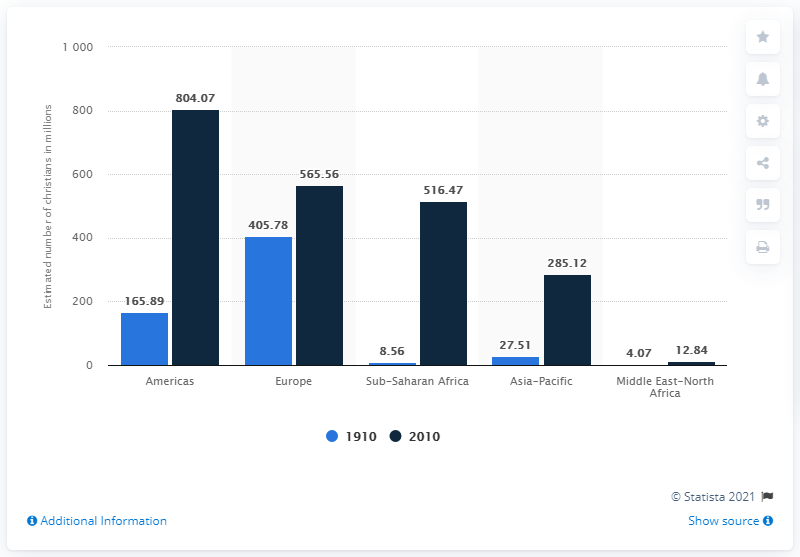Mention a couple of crucial points in this snapshot. In 1910, there were approximately 405.78 million Christians living in Europe. In 2010, there were approximately 565.56 million Christians in Europe. 